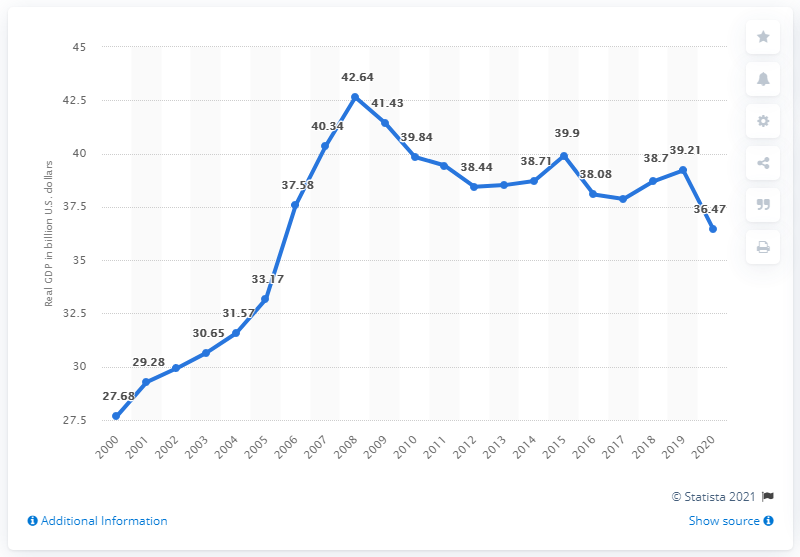List a handful of essential elements in this visual. In 2020, the Gross Domestic Product (GDP) of Wyoming was 36.47 billion dollars. In the previous year, the Gross Domestic Product (GDP) of Wyoming was 39.21 dollars. 